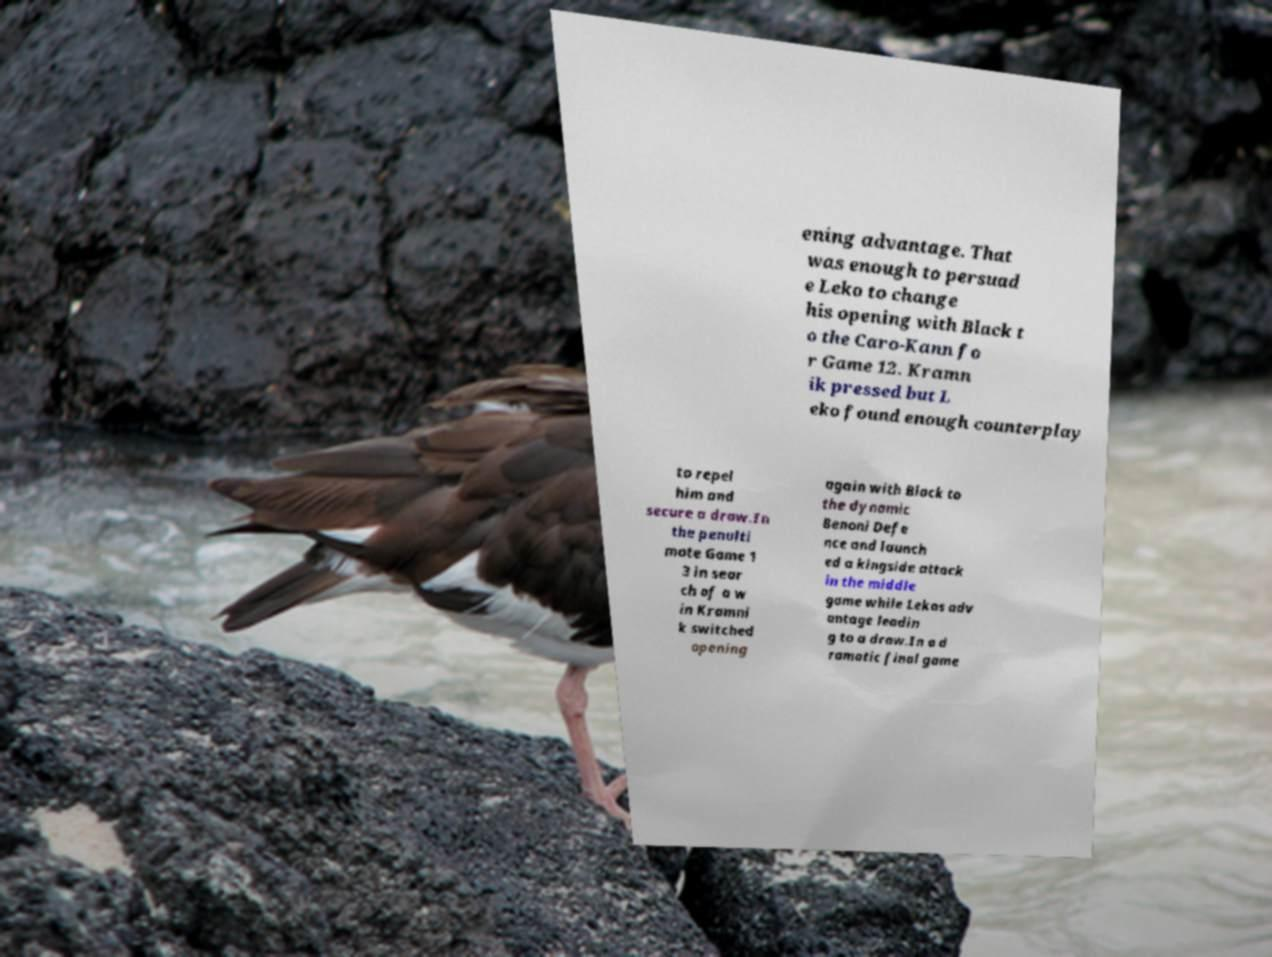I need the written content from this picture converted into text. Can you do that? ening advantage. That was enough to persuad e Leko to change his opening with Black t o the Caro-Kann fo r Game 12. Kramn ik pressed but L eko found enough counterplay to repel him and secure a draw.In the penulti mate Game 1 3 in sear ch of a w in Kramni k switched opening again with Black to the dynamic Benoni Defe nce and launch ed a kingside attack in the middle game while Lekos adv antage leadin g to a draw.In a d ramatic final game 